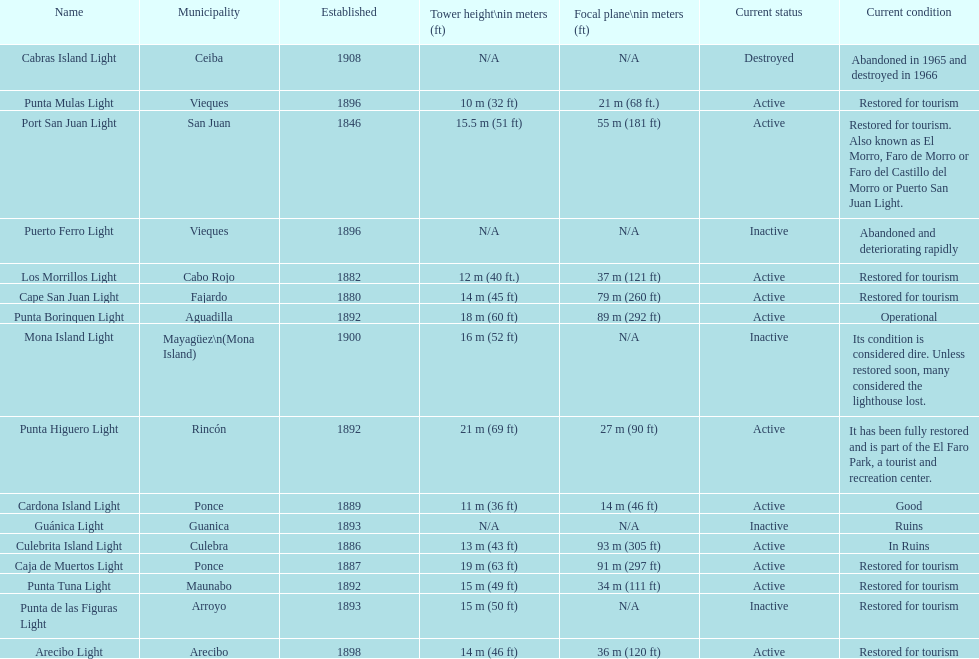Names of municipalities established before 1880 San Juan. 